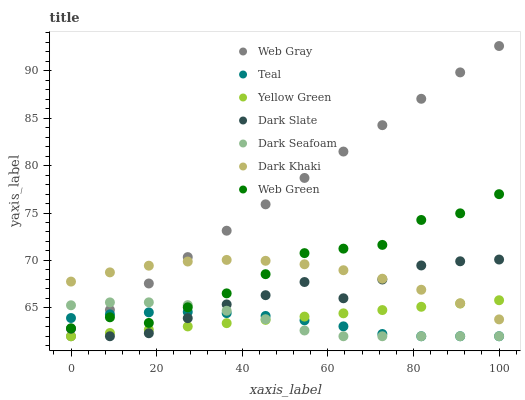Does Teal have the minimum area under the curve?
Answer yes or no. Yes. Does Web Gray have the maximum area under the curve?
Answer yes or no. Yes. Does Yellow Green have the minimum area under the curve?
Answer yes or no. No. Does Yellow Green have the maximum area under the curve?
Answer yes or no. No. Is Yellow Green the smoothest?
Answer yes or no. Yes. Is Web Green the roughest?
Answer yes or no. Yes. Is Web Green the smoothest?
Answer yes or no. No. Is Yellow Green the roughest?
Answer yes or no. No. Does Web Gray have the lowest value?
Answer yes or no. Yes. Does Web Green have the lowest value?
Answer yes or no. No. Does Web Gray have the highest value?
Answer yes or no. Yes. Does Yellow Green have the highest value?
Answer yes or no. No. Is Dark Slate less than Web Green?
Answer yes or no. Yes. Is Web Green greater than Dark Slate?
Answer yes or no. Yes. Does Web Green intersect Web Gray?
Answer yes or no. Yes. Is Web Green less than Web Gray?
Answer yes or no. No. Is Web Green greater than Web Gray?
Answer yes or no. No. Does Dark Slate intersect Web Green?
Answer yes or no. No. 